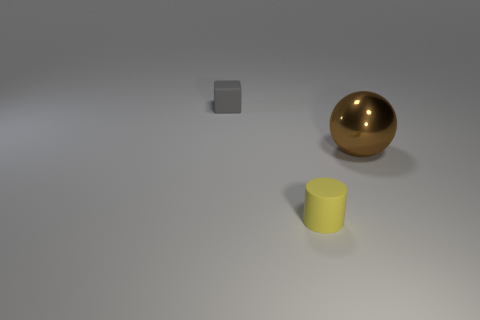Add 2 tiny gray things. How many objects exist? 5 Subtract all balls. How many objects are left? 2 Subtract all green metallic objects. Subtract all gray rubber things. How many objects are left? 2 Add 1 tiny rubber cylinders. How many tiny rubber cylinders are left? 2 Add 3 brown metallic things. How many brown metallic things exist? 4 Subtract 0 gray balls. How many objects are left? 3 